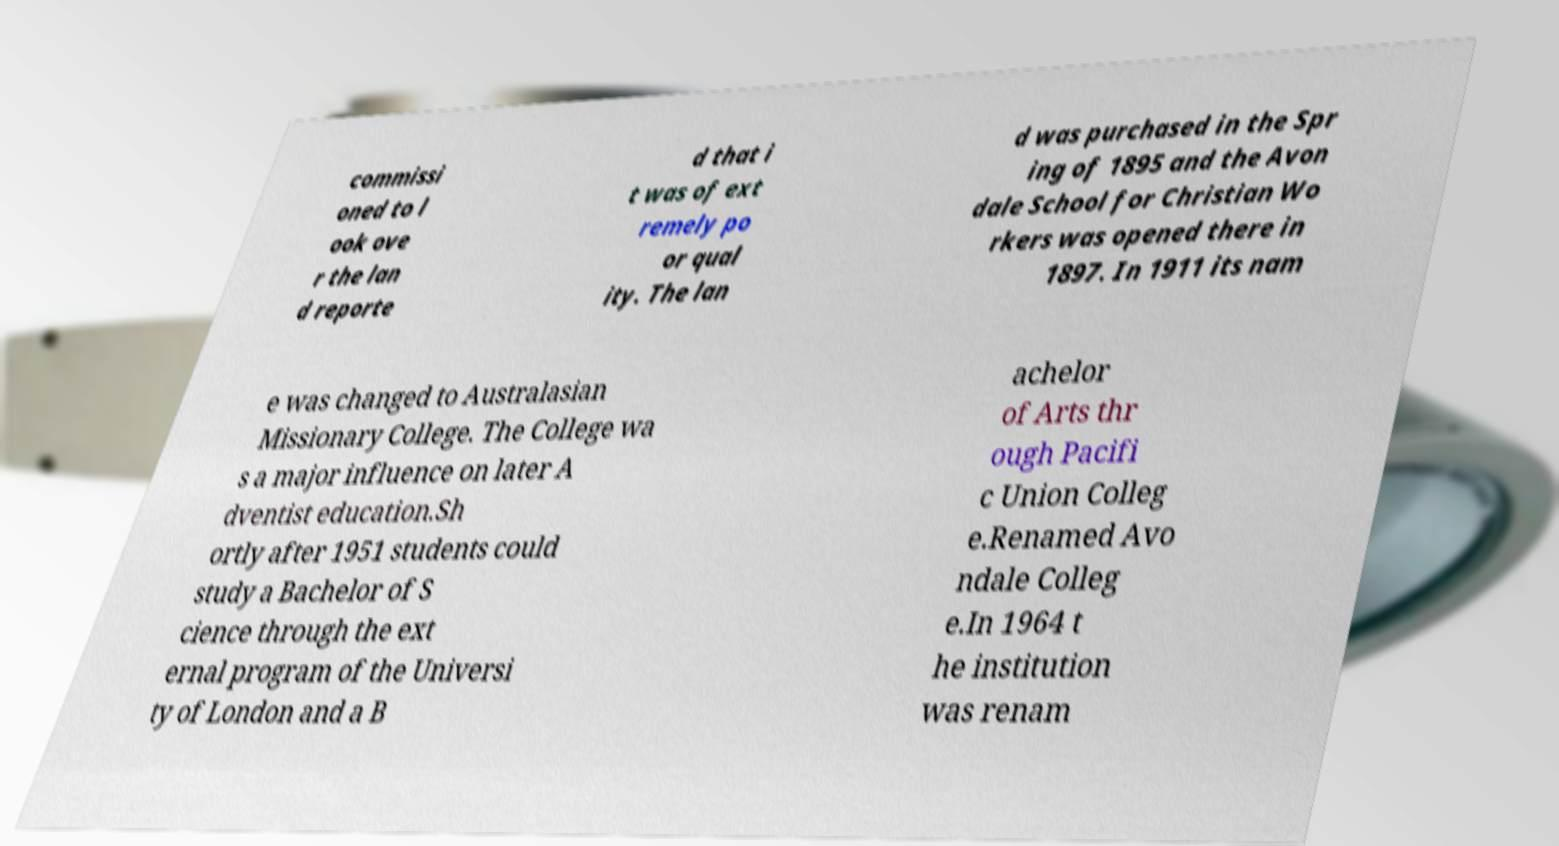Could you extract and type out the text from this image? commissi oned to l ook ove r the lan d reporte d that i t was of ext remely po or qual ity. The lan d was purchased in the Spr ing of 1895 and the Avon dale School for Christian Wo rkers was opened there in 1897. In 1911 its nam e was changed to Australasian Missionary College. The College wa s a major influence on later A dventist education.Sh ortly after 1951 students could study a Bachelor of S cience through the ext ernal program of the Universi ty of London and a B achelor of Arts thr ough Pacifi c Union Colleg e.Renamed Avo ndale Colleg e.In 1964 t he institution was renam 